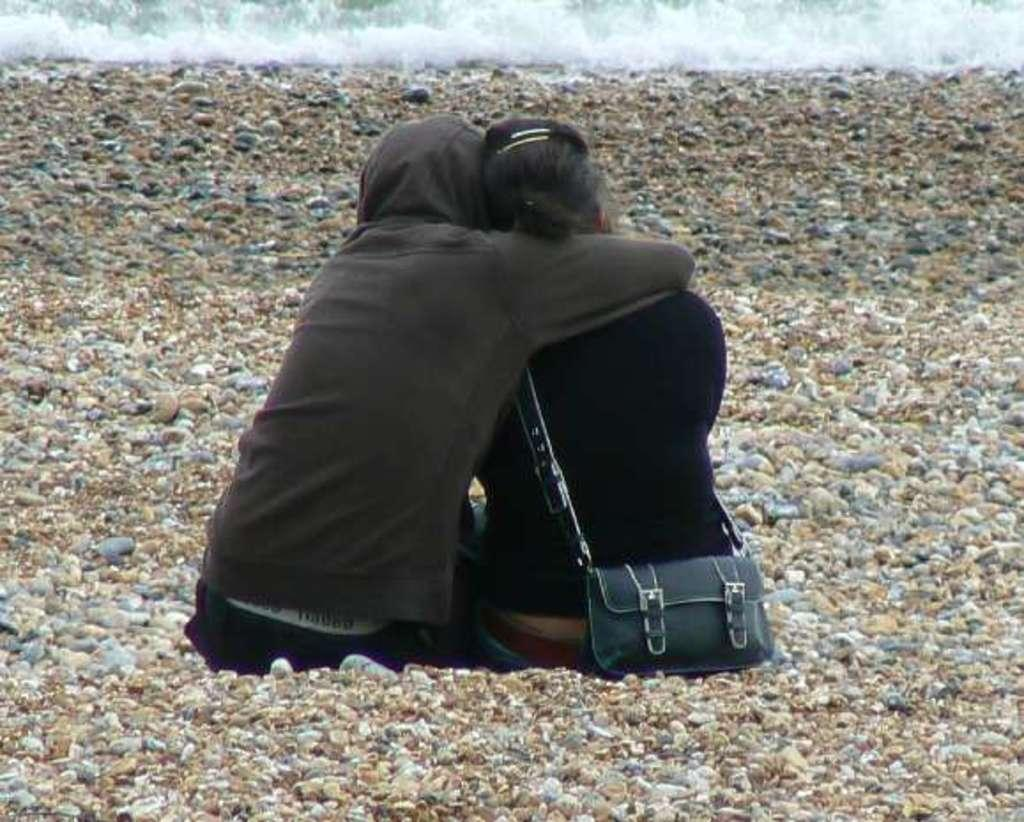How many people are in the image? There are two persons in the image. What are the persons doing in the image? The persons are sitting on stones. What is visible near the stones? There is water visible near the stones. What type of art can be seen on the nose of one of the persons in the image? There is no art or any reference to a nose present in the image. 